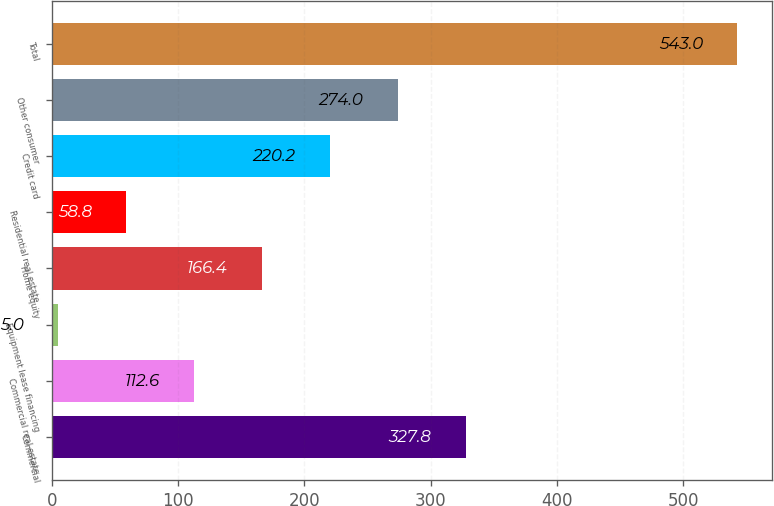Convert chart. <chart><loc_0><loc_0><loc_500><loc_500><bar_chart><fcel>Commercial<fcel>Commercial real estate<fcel>Equipment lease financing<fcel>Home equity<fcel>Residential real estate<fcel>Credit card<fcel>Other consumer<fcel>Total<nl><fcel>327.8<fcel>112.6<fcel>5<fcel>166.4<fcel>58.8<fcel>220.2<fcel>274<fcel>543<nl></chart> 